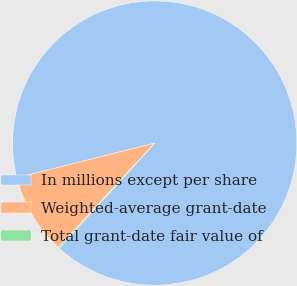Convert chart to OTSL. <chart><loc_0><loc_0><loc_500><loc_500><pie_chart><fcel>In millions except per share<fcel>Weighted-average grant-date<fcel>Total grant-date fair value of<nl><fcel>90.66%<fcel>9.2%<fcel>0.14%<nl></chart> 